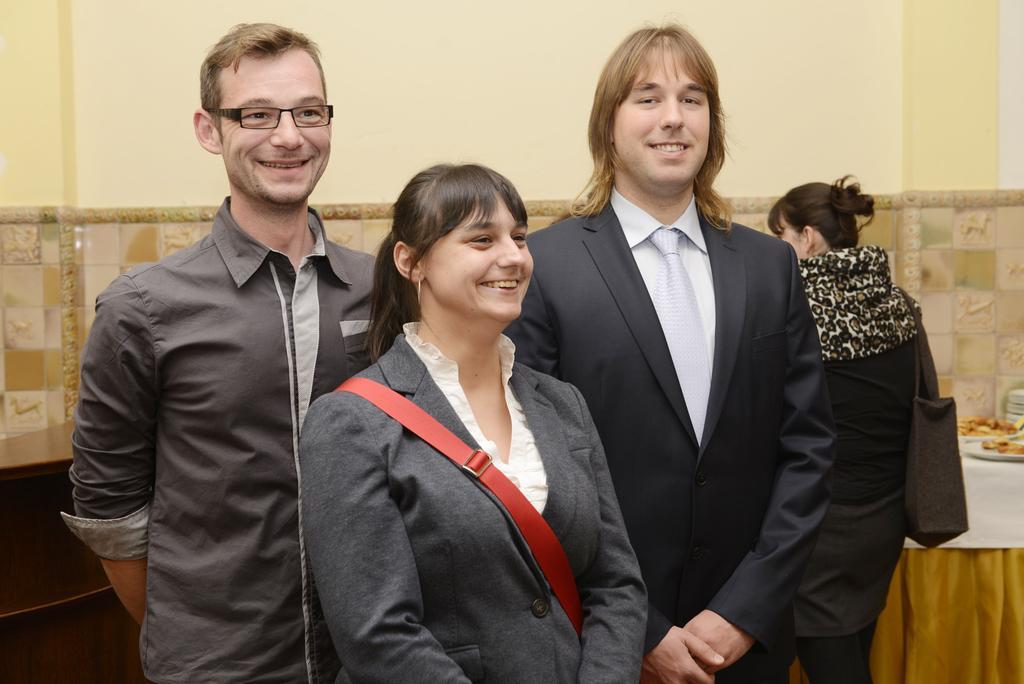Could you give a brief overview of what you see in this image? In this image we can see persons standing on the ground. In the background we can see serving plates with food, cloth and wall. 